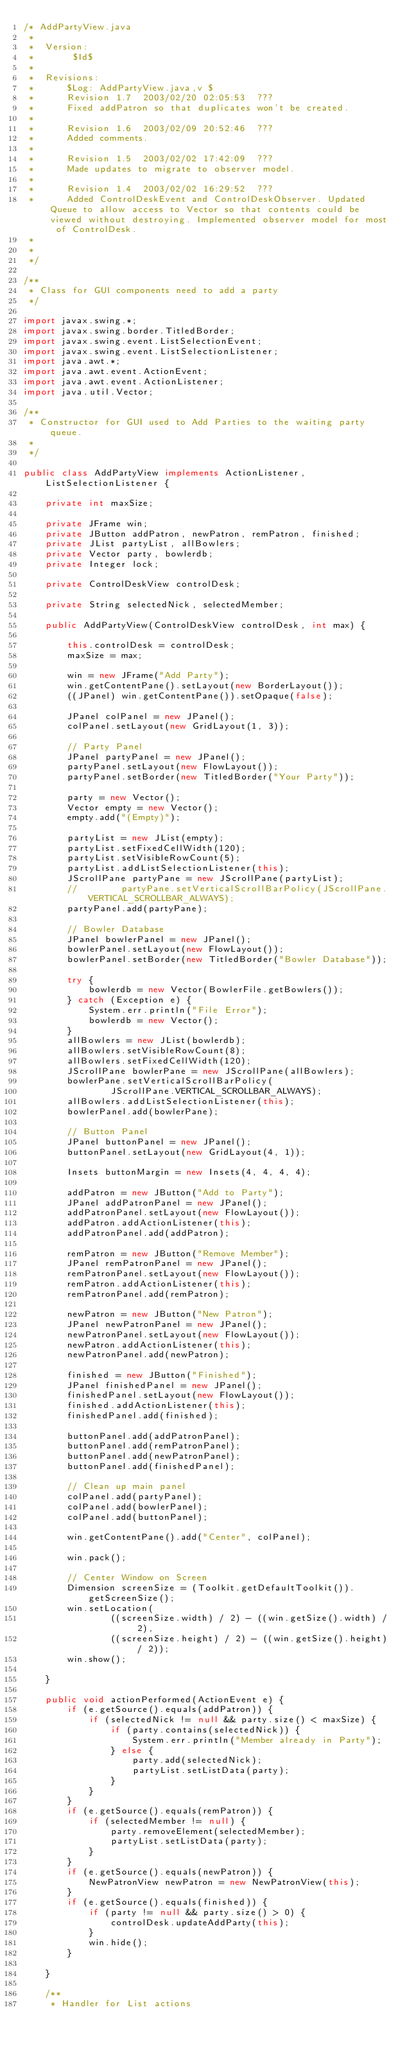<code> <loc_0><loc_0><loc_500><loc_500><_Java_>/* AddPartyView.java
 *
 *  Version:
 * 		 $Id$
 * 
 *  Revisions:
 * 		$Log: AddPartyView.java,v $
 * 		Revision 1.7  2003/02/20 02:05:53  ???
 * 		Fixed addPatron so that duplicates won't be created.
 * 		
 * 		Revision 1.6  2003/02/09 20:52:46  ???
 * 		Added comments.
 * 		
 * 		Revision 1.5  2003/02/02 17:42:09  ???
 * 		Made updates to migrate to observer model.
 * 		
 * 		Revision 1.4  2003/02/02 16:29:52  ???
 * 		Added ControlDeskEvent and ControlDeskObserver. Updated Queue to allow access to Vector so that contents could be viewed without destroying. Implemented observer model for most of ControlDesk.
 * 		
 * 
 */

/**
 * Class for GUI components need to add a party
 */

import javax.swing.*;
import javax.swing.border.TitledBorder;
import javax.swing.event.ListSelectionEvent;
import javax.swing.event.ListSelectionListener;
import java.awt.*;
import java.awt.event.ActionEvent;
import java.awt.event.ActionListener;
import java.util.Vector;

/**
 * Constructor for GUI used to Add Parties to the waiting party queue.
 *
 */

public class AddPartyView implements ActionListener, ListSelectionListener {

    private int maxSize;

    private JFrame win;
    private JButton addPatron, newPatron, remPatron, finished;
    private JList partyList, allBowlers;
    private Vector party, bowlerdb;
    private Integer lock;

    private ControlDeskView controlDesk;

    private String selectedNick, selectedMember;

    public AddPartyView(ControlDeskView controlDesk, int max) {

        this.controlDesk = controlDesk;
        maxSize = max;

        win = new JFrame("Add Party");
        win.getContentPane().setLayout(new BorderLayout());
        ((JPanel) win.getContentPane()).setOpaque(false);

        JPanel colPanel = new JPanel();
        colPanel.setLayout(new GridLayout(1, 3));

        // Party Panel
        JPanel partyPanel = new JPanel();
        partyPanel.setLayout(new FlowLayout());
        partyPanel.setBorder(new TitledBorder("Your Party"));

        party = new Vector();
        Vector empty = new Vector();
        empty.add("(Empty)");

        partyList = new JList(empty);
        partyList.setFixedCellWidth(120);
        partyList.setVisibleRowCount(5);
        partyList.addListSelectionListener(this);
        JScrollPane partyPane = new JScrollPane(partyList);
        //        partyPane.setVerticalScrollBarPolicy(JScrollPane.VERTICAL_SCROLLBAR_ALWAYS);
        partyPanel.add(partyPane);

        // Bowler Database
        JPanel bowlerPanel = new JPanel();
        bowlerPanel.setLayout(new FlowLayout());
        bowlerPanel.setBorder(new TitledBorder("Bowler Database"));

        try {
            bowlerdb = new Vector(BowlerFile.getBowlers());
        } catch (Exception e) {
            System.err.println("File Error");
            bowlerdb = new Vector();
        }
        allBowlers = new JList(bowlerdb);
        allBowlers.setVisibleRowCount(8);
        allBowlers.setFixedCellWidth(120);
        JScrollPane bowlerPane = new JScrollPane(allBowlers);
        bowlerPane.setVerticalScrollBarPolicy(
                JScrollPane.VERTICAL_SCROLLBAR_ALWAYS);
        allBowlers.addListSelectionListener(this);
        bowlerPanel.add(bowlerPane);

        // Button Panel
        JPanel buttonPanel = new JPanel();
        buttonPanel.setLayout(new GridLayout(4, 1));

        Insets buttonMargin = new Insets(4, 4, 4, 4);

        addPatron = new JButton("Add to Party");
        JPanel addPatronPanel = new JPanel();
        addPatronPanel.setLayout(new FlowLayout());
        addPatron.addActionListener(this);
        addPatronPanel.add(addPatron);

        remPatron = new JButton("Remove Member");
        JPanel remPatronPanel = new JPanel();
        remPatronPanel.setLayout(new FlowLayout());
        remPatron.addActionListener(this);
        remPatronPanel.add(remPatron);

        newPatron = new JButton("New Patron");
        JPanel newPatronPanel = new JPanel();
        newPatronPanel.setLayout(new FlowLayout());
        newPatron.addActionListener(this);
        newPatronPanel.add(newPatron);

        finished = new JButton("Finished");
        JPanel finishedPanel = new JPanel();
        finishedPanel.setLayout(new FlowLayout());
        finished.addActionListener(this);
        finishedPanel.add(finished);

        buttonPanel.add(addPatronPanel);
        buttonPanel.add(remPatronPanel);
        buttonPanel.add(newPatronPanel);
        buttonPanel.add(finishedPanel);

        // Clean up main panel
        colPanel.add(partyPanel);
        colPanel.add(bowlerPanel);
        colPanel.add(buttonPanel);

        win.getContentPane().add("Center", colPanel);

        win.pack();

        // Center Window on Screen
        Dimension screenSize = (Toolkit.getDefaultToolkit()).getScreenSize();
        win.setLocation(
                ((screenSize.width) / 2) - ((win.getSize().width) / 2),
                ((screenSize.height) / 2) - ((win.getSize().height) / 2));
        win.show();

    }

    public void actionPerformed(ActionEvent e) {
        if (e.getSource().equals(addPatron)) {
            if (selectedNick != null && party.size() < maxSize) {
                if (party.contains(selectedNick)) {
                    System.err.println("Member already in Party");
                } else {
                    party.add(selectedNick);
                    partyList.setListData(party);
                }
            }
        }
        if (e.getSource().equals(remPatron)) {
            if (selectedMember != null) {
                party.removeElement(selectedMember);
                partyList.setListData(party);
            }
        }
        if (e.getSource().equals(newPatron)) {
            NewPatronView newPatron = new NewPatronView(this);
        }
        if (e.getSource().equals(finished)) {
            if (party != null && party.size() > 0) {
                controlDesk.updateAddParty(this);
            }
            win.hide();
        }

    }

    /**
     * Handler for List actions</code> 